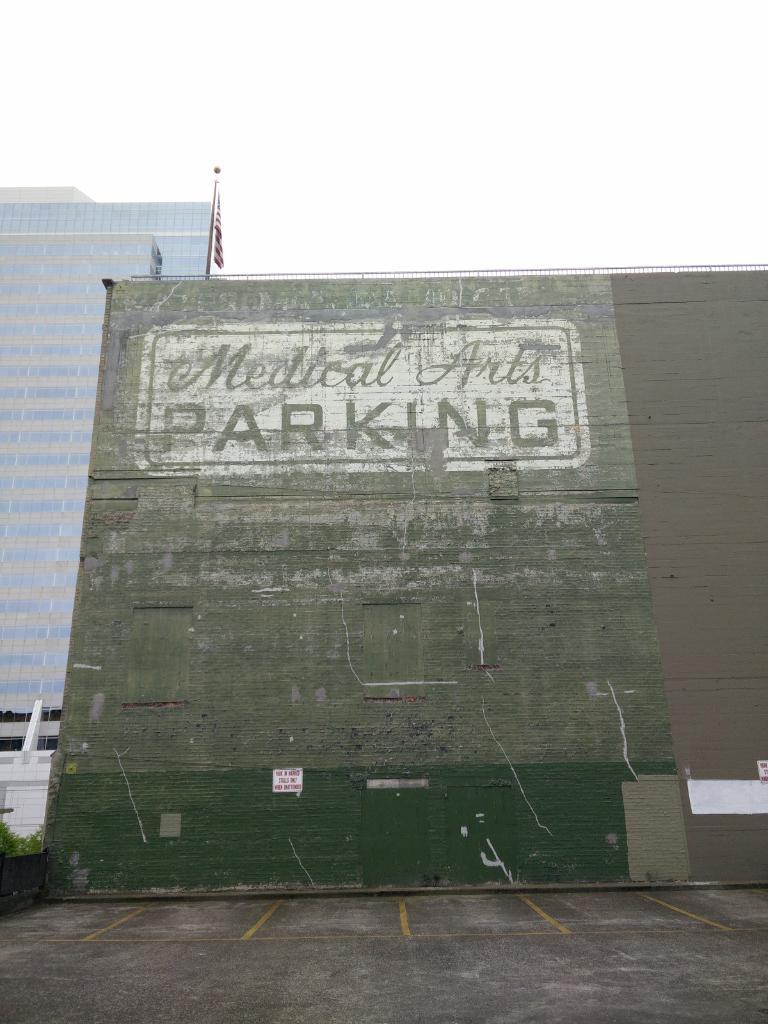What is present on the wall in the image? There is text on the wall in the image. What else can be seen in the image besides the wall? There are plants, a flag on a pole, tower buildings, and the sky visible in the background. Can you describe the flag in the image? The flag is on a pole in the image. What type of structures are visible in the image? Tower buildings are visible in the image. What type of rifle is being used by the person standing next to the wall in the image? There is no person or rifle present in the image; it only features a wall with text, plants, a flag, tower buildings, and the sky. 